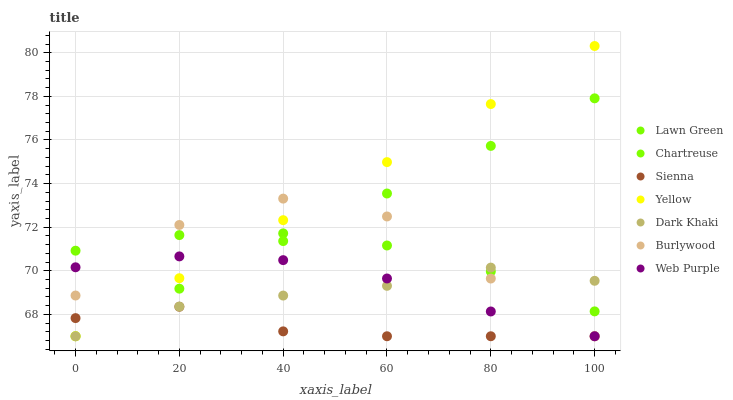Does Sienna have the minimum area under the curve?
Answer yes or no. Yes. Does Yellow have the maximum area under the curve?
Answer yes or no. Yes. Does Burlywood have the minimum area under the curve?
Answer yes or no. No. Does Burlywood have the maximum area under the curve?
Answer yes or no. No. Is Chartreuse the smoothest?
Answer yes or no. Yes. Is Burlywood the roughest?
Answer yes or no. Yes. Is Web Purple the smoothest?
Answer yes or no. No. Is Web Purple the roughest?
Answer yes or no. No. Does Burlywood have the lowest value?
Answer yes or no. Yes. Does Yellow have the highest value?
Answer yes or no. Yes. Does Burlywood have the highest value?
Answer yes or no. No. Is Sienna less than Lawn Green?
Answer yes or no. Yes. Is Lawn Green greater than Web Purple?
Answer yes or no. Yes. Does Sienna intersect Chartreuse?
Answer yes or no. Yes. Is Sienna less than Chartreuse?
Answer yes or no. No. Is Sienna greater than Chartreuse?
Answer yes or no. No. Does Sienna intersect Lawn Green?
Answer yes or no. No. 